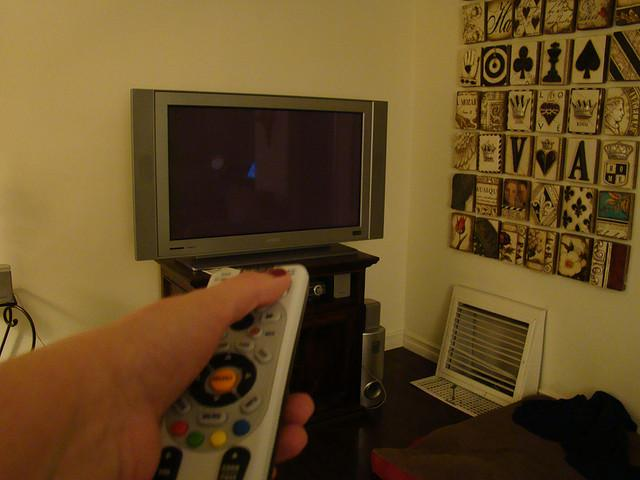What does this person want to do? watch tv 